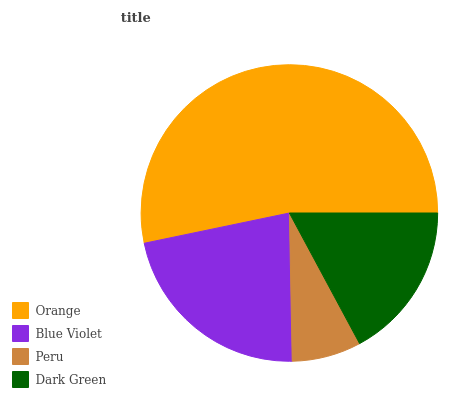Is Peru the minimum?
Answer yes or no. Yes. Is Orange the maximum?
Answer yes or no. Yes. Is Blue Violet the minimum?
Answer yes or no. No. Is Blue Violet the maximum?
Answer yes or no. No. Is Orange greater than Blue Violet?
Answer yes or no. Yes. Is Blue Violet less than Orange?
Answer yes or no. Yes. Is Blue Violet greater than Orange?
Answer yes or no. No. Is Orange less than Blue Violet?
Answer yes or no. No. Is Blue Violet the high median?
Answer yes or no. Yes. Is Dark Green the low median?
Answer yes or no. Yes. Is Orange the high median?
Answer yes or no. No. Is Orange the low median?
Answer yes or no. No. 